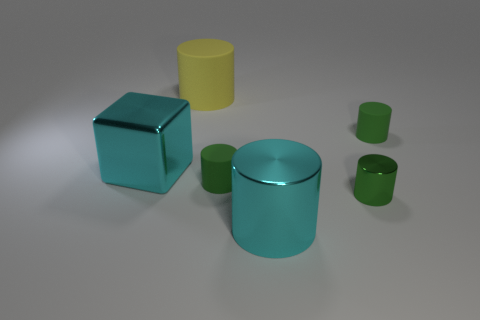Subtract all green cylinders. How many were subtracted if there are2green cylinders left? 1 Subtract all cyan blocks. How many green cylinders are left? 3 Subtract all yellow cylinders. How many cylinders are left? 4 Subtract all big cyan cylinders. How many cylinders are left? 4 Subtract all blue cylinders. Subtract all green balls. How many cylinders are left? 5 Add 3 tiny things. How many objects exist? 9 Subtract all cylinders. How many objects are left? 1 Add 1 rubber objects. How many rubber objects exist? 4 Subtract 0 blue balls. How many objects are left? 6 Subtract all large metallic cylinders. Subtract all yellow rubber cylinders. How many objects are left? 4 